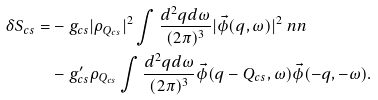Convert formula to latex. <formula><loc_0><loc_0><loc_500><loc_500>\delta S _ { c s } = & - g _ { c s } | \rho _ { Q _ { c s } } | ^ { 2 } \int \frac { d ^ { 2 } q d \omega } { ( 2 \pi ) ^ { 3 } } | \vec { \phi } ( q , \omega ) | ^ { 2 } \ n n \\ & - g ^ { \prime } _ { c s } \rho _ { Q _ { c s } } \int \frac { d ^ { 2 } q d \omega } { ( 2 \pi ) ^ { 3 } } \vec { \phi } ( q - Q _ { c s } , \omega ) \vec { \phi } ( - q , - \omega ) .</formula> 